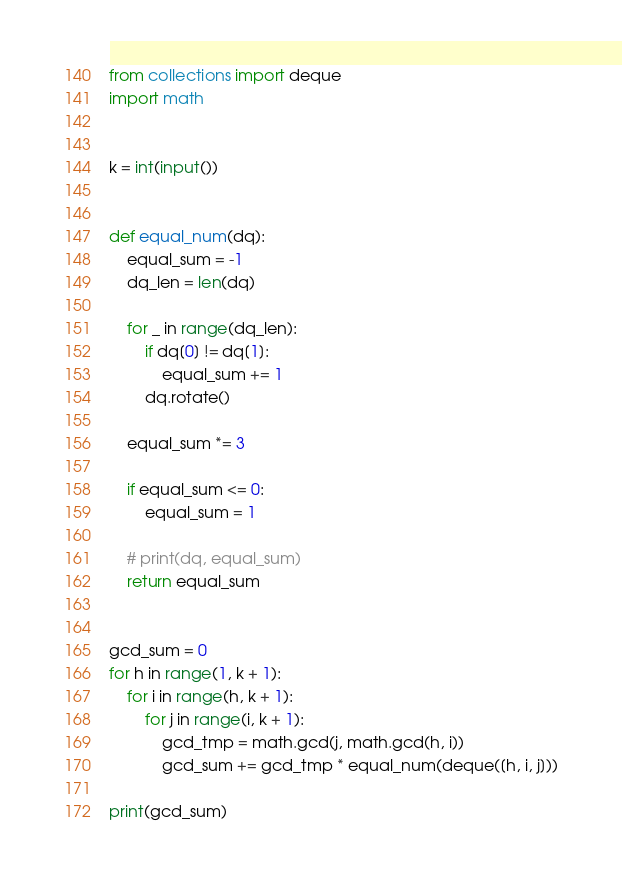Convert code to text. <code><loc_0><loc_0><loc_500><loc_500><_Python_>from collections import deque
import math


k = int(input())


def equal_num(dq):
    equal_sum = -1
    dq_len = len(dq)

    for _ in range(dq_len):
        if dq[0] != dq[1]:
            equal_sum += 1
        dq.rotate()

    equal_sum *= 3

    if equal_sum <= 0:
        equal_sum = 1

    # print(dq, equal_sum)
    return equal_sum


gcd_sum = 0
for h in range(1, k + 1):
    for i in range(h, k + 1):
        for j in range(i, k + 1):
            gcd_tmp = math.gcd(j, math.gcd(h, i))
            gcd_sum += gcd_tmp * equal_num(deque([h, i, j]))

print(gcd_sum)</code> 